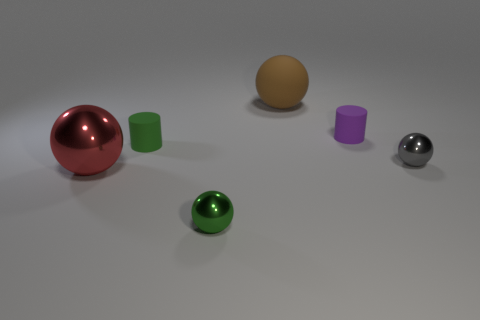What is the size of the shiny sphere behind the big ball that is to the left of the brown thing?
Your answer should be very brief. Small. What material is the red sphere that is the same size as the brown rubber thing?
Your answer should be very brief. Metal. What number of other things are the same size as the green ball?
Your answer should be very brief. 3. What number of cylinders are either green rubber objects or small green objects?
Your response must be concise. 1. What material is the big thing that is in front of the matte cylinder that is on the right side of the tiny shiny sphere that is in front of the red ball made of?
Give a very brief answer. Metal. What number of tiny green cylinders have the same material as the tiny purple cylinder?
Provide a succinct answer. 1. Does the red metal object that is left of the matte sphere have the same size as the large rubber object?
Give a very brief answer. Yes. The other tiny object that is the same material as the gray thing is what color?
Make the answer very short. Green. There is a small green metallic thing; what number of gray balls are right of it?
Your answer should be compact. 1. Do the small object in front of the small gray shiny sphere and the small matte object to the left of the tiny green metallic thing have the same color?
Offer a terse response. Yes. 